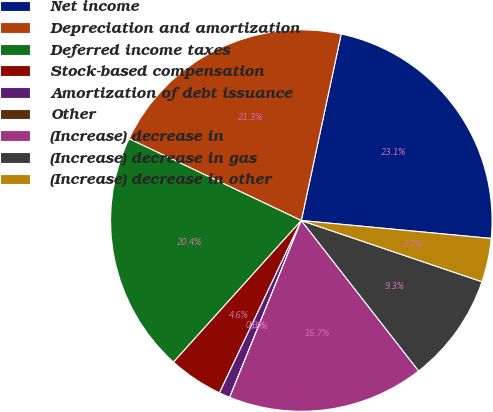Convert chart. <chart><loc_0><loc_0><loc_500><loc_500><pie_chart><fcel>Net income<fcel>Depreciation and amortization<fcel>Deferred income taxes<fcel>Stock-based compensation<fcel>Amortization of debt issuance<fcel>Other<fcel>(Increase) decrease in<fcel>(Increase) decrease in gas<fcel>(Increase) decrease in other<nl><fcel>23.15%<fcel>21.3%<fcel>20.37%<fcel>4.63%<fcel>0.93%<fcel>0.0%<fcel>16.67%<fcel>9.26%<fcel>3.7%<nl></chart> 